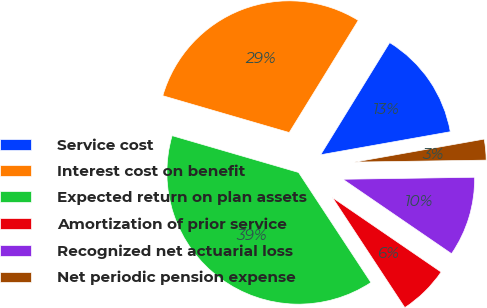Convert chart to OTSL. <chart><loc_0><loc_0><loc_500><loc_500><pie_chart><fcel>Service cost<fcel>Interest cost on benefit<fcel>Expected return on plan assets<fcel>Amortization of prior service<fcel>Recognized net actuarial loss<fcel>Net periodic pension expense<nl><fcel>13.42%<fcel>29.27%<fcel>38.76%<fcel>6.18%<fcel>9.8%<fcel>2.56%<nl></chart> 